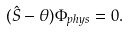<formula> <loc_0><loc_0><loc_500><loc_500>( \hat { S } - \theta ) \Phi _ { p h y s } = 0 .</formula> 